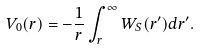Convert formula to latex. <formula><loc_0><loc_0><loc_500><loc_500>V _ { 0 } ( r ) = - \frac { 1 } { r } \int _ { r } ^ { \infty } W _ { S } ( r ^ { \prime } ) d r ^ { \prime } .</formula> 